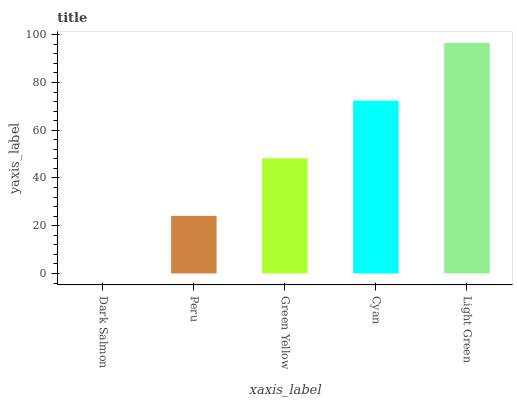Is Dark Salmon the minimum?
Answer yes or no. Yes. Is Light Green the maximum?
Answer yes or no. Yes. Is Peru the minimum?
Answer yes or no. No. Is Peru the maximum?
Answer yes or no. No. Is Peru greater than Dark Salmon?
Answer yes or no. Yes. Is Dark Salmon less than Peru?
Answer yes or no. Yes. Is Dark Salmon greater than Peru?
Answer yes or no. No. Is Peru less than Dark Salmon?
Answer yes or no. No. Is Green Yellow the high median?
Answer yes or no. Yes. Is Green Yellow the low median?
Answer yes or no. Yes. Is Dark Salmon the high median?
Answer yes or no. No. Is Light Green the low median?
Answer yes or no. No. 